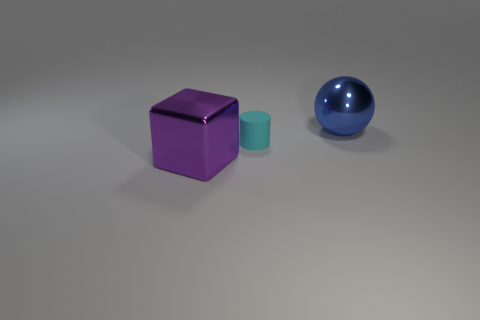What is the shape of the big blue object?
Give a very brief answer. Sphere. There is a metallic object that is in front of the large thing that is to the right of the cyan matte cylinder; what size is it?
Offer a very short reply. Large. What number of things are large blue objects or big red things?
Give a very brief answer. 1. Does the tiny object have the same shape as the purple metal object?
Offer a terse response. No. Is there a large blue ball made of the same material as the purple thing?
Your answer should be compact. Yes. Is there a large sphere on the left side of the big object behind the purple metal thing?
Ensure brevity in your answer.  No. There is a blue sphere to the right of the purple object; is its size the same as the tiny matte thing?
Offer a very short reply. No. The cyan matte object is what size?
Offer a terse response. Small. Is there a metallic object of the same color as the cylinder?
Your answer should be very brief. No. What number of small objects are balls or cyan objects?
Keep it short and to the point. 1. 